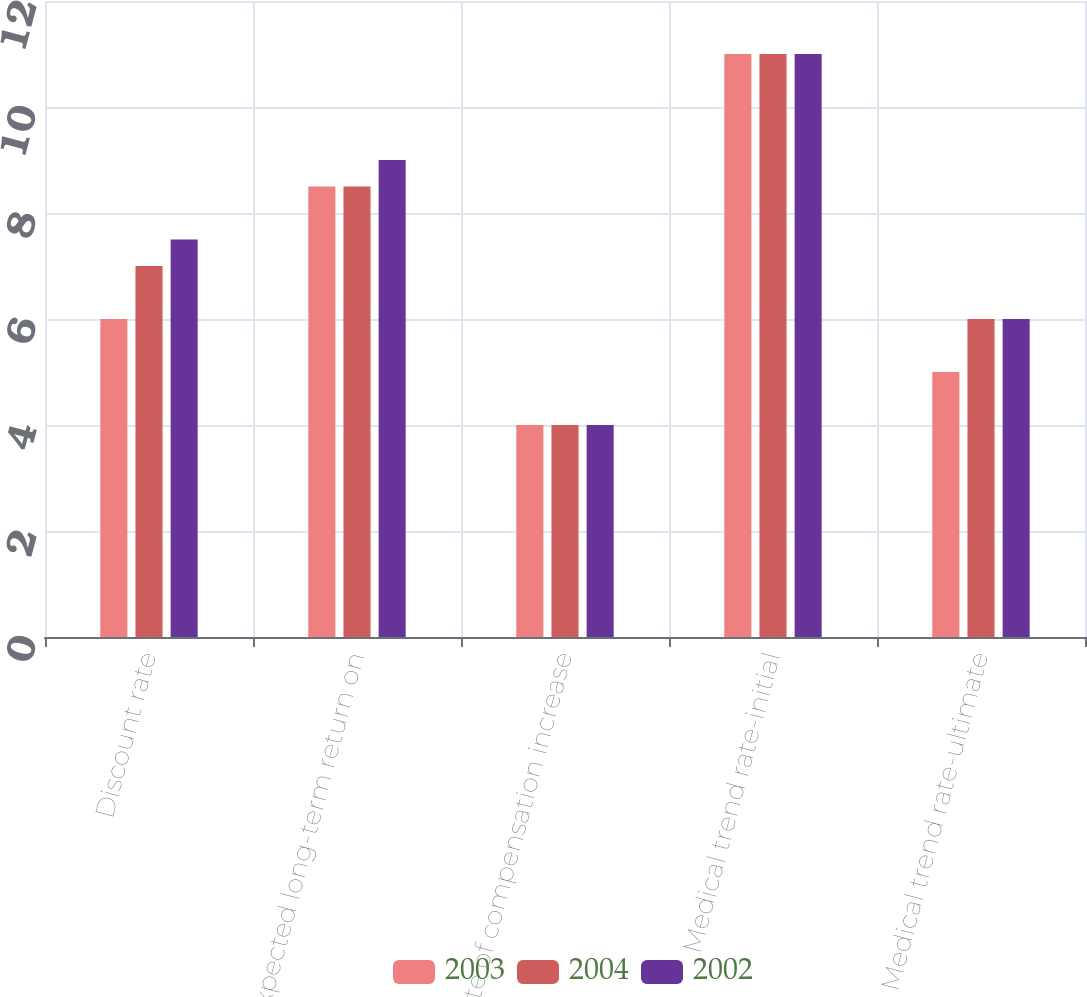Convert chart to OTSL. <chart><loc_0><loc_0><loc_500><loc_500><stacked_bar_chart><ecel><fcel>Discount rate<fcel>Expected long-term return on<fcel>Rate of compensation increase<fcel>Medical trend rate-initial<fcel>Medical trend rate-ultimate<nl><fcel>2003<fcel>6<fcel>8.5<fcel>4<fcel>11<fcel>5<nl><fcel>2004<fcel>7<fcel>8.5<fcel>4<fcel>11<fcel>6<nl><fcel>2002<fcel>7.5<fcel>9<fcel>4<fcel>11<fcel>6<nl></chart> 